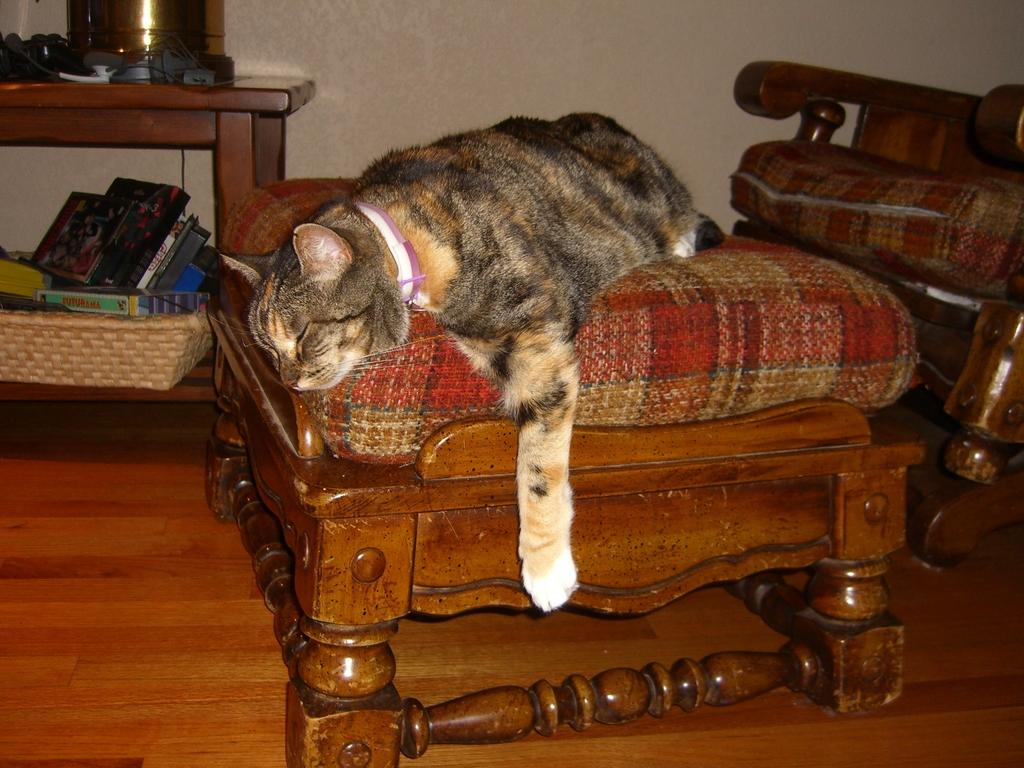What type of animal is in the image? There is a cat in the image. What is the cat doing in the image? The cat is sleeping in the image. Where is the cat located in the image? The cat is on a stool in the image. What is on the stool that the cat is sitting on? The stool has a cushion in the image. What type of music can be heard coming from the lake in the image? There is no lake or music present in the image; it features a cat sleeping on a stool with a cushion. 